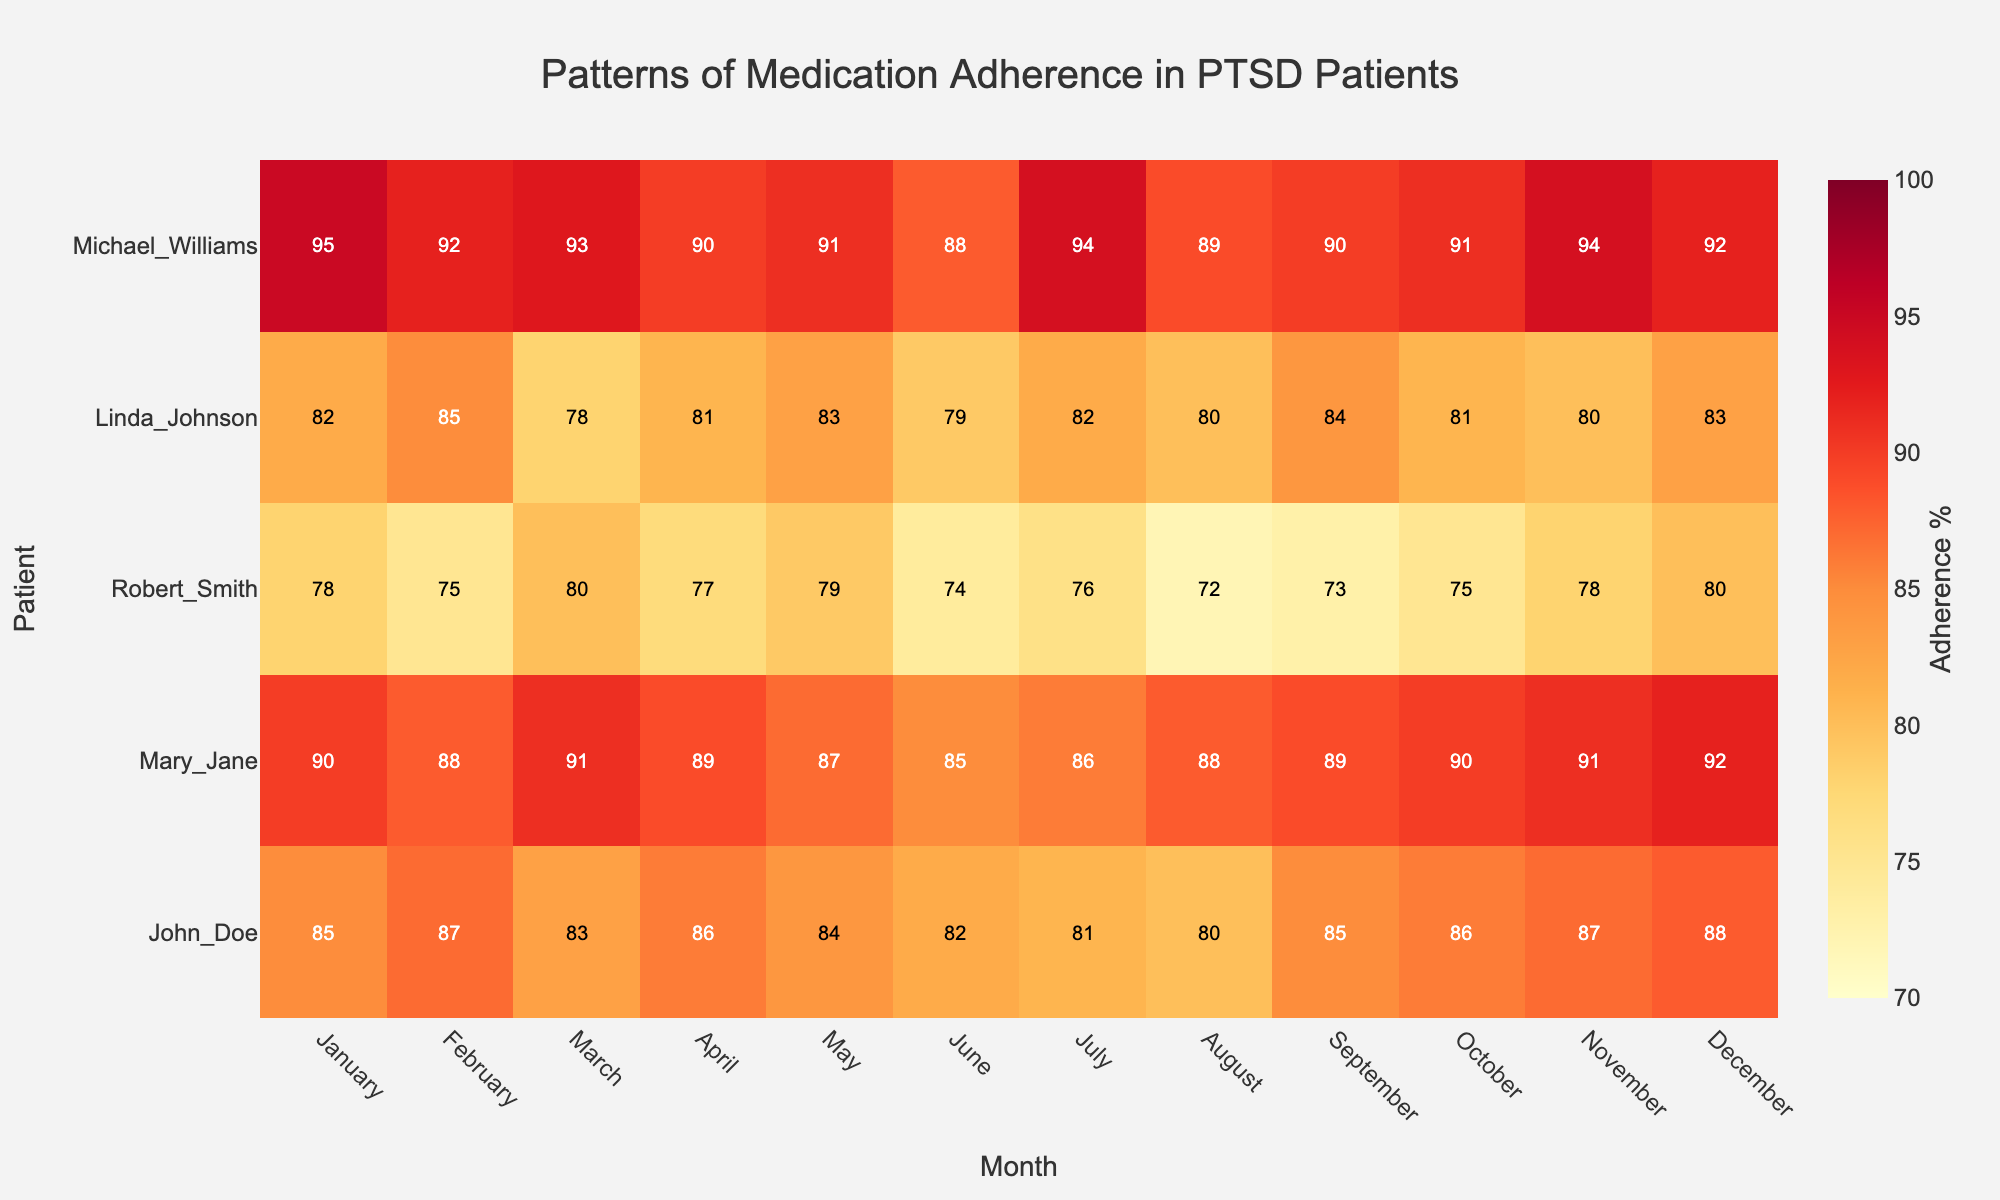What is the title of the heatmap? The title of the heatmap is located at the top center of the figure. It summarizes the graph’s purpose or the data it represents.
Answer: Patterns of Medication Adherence in PTSD Patients Which month shows the highest medication adherence for Robert Smith? Identify the row corresponding to Robert Smith, then look for the highest value in that row to find the corresponding month.
Answer: March and December How many months does Mary Jane have an adherence percentage of 90 or higher? Check the row corresponding to Mary Jane and count the number of cells with values 90 or higher.
Answer: 7 months What is the range of the adherence percentage for John Doe across all months? Find the minimum and maximum adherence values for John Doe and calculate the range (maximum - minimum).
Answer: 7 Compare the adherence percentage between John Doe and Michael Williams in July. Who has higher adherence? Locate the adherence values for both John Doe and Michael Williams for the month of July and compare them.
Answer: Michael Williams What is the overall adherence trend for Linda Johnson throughout the year? Observe the row corresponding to Linda Johnson and analyze the changes in adherence values across the months to identify whether it generally increases, decreases, or fluctuates.
Answer: Fluctuates In which month does Michael Williams show the lowest adherence? Identify the row corresponding to Michael Williams and find the minimum adherence value and its corresponding month.
Answer: June How does the adherence pattern of Mary Jane compare to that of Linda Johnson over the months? Compare the adherence values in each month for both Mary Jane and Linda Johnson to see if there are any significant differences or similarities.
Answer: Mary Jane generally has higher adherence than Linda Johnson What is the average adherence percentage for Robert Smith in the first half of the year (January to June)? Add the adherence percentages for Robert Smith from January to June, then divide by the number of months to get the average.
Answer: 77.2% Which patient has the most consistent adherence percentage across the year? Calculate the standard deviation of adherence percentages for each patient and identify the patient with the lowest standard deviation.
Answer: Mary Jane 